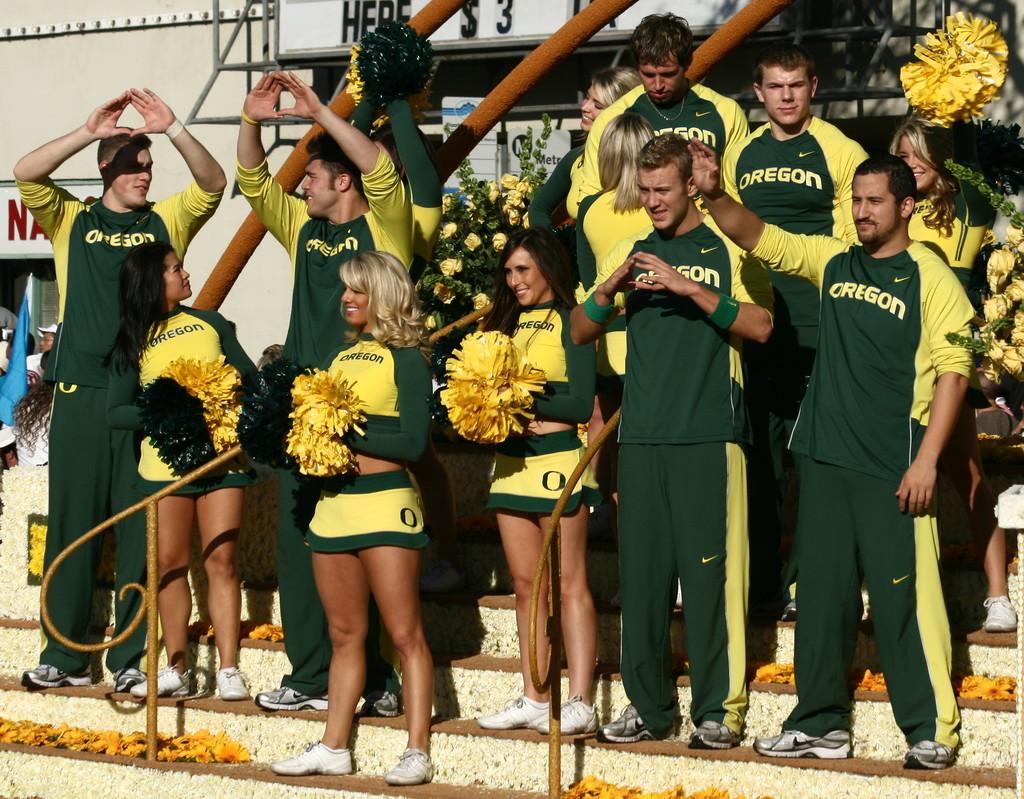Which school team is this?
Make the answer very short. Oregon. 